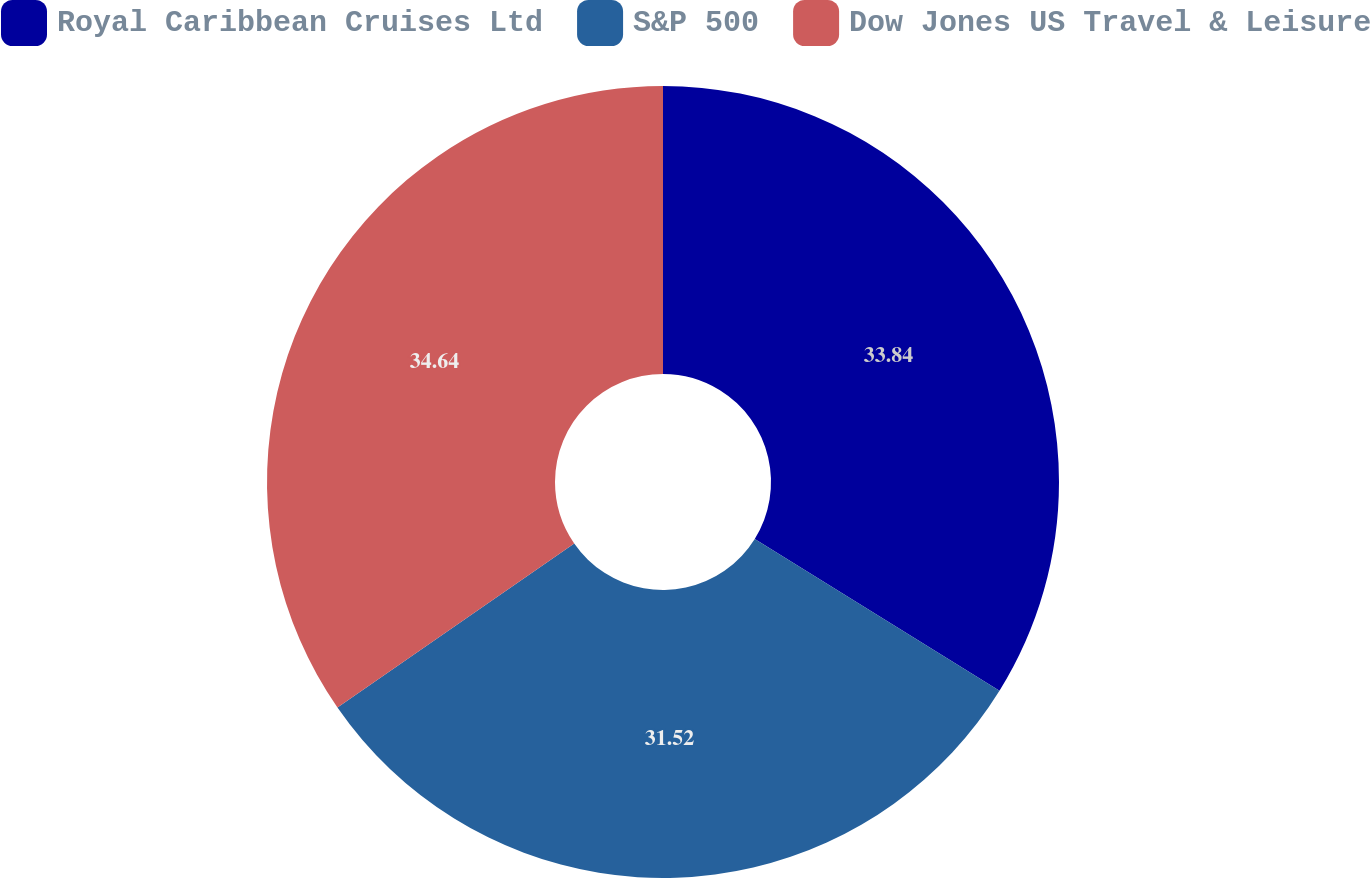<chart> <loc_0><loc_0><loc_500><loc_500><pie_chart><fcel>Royal Caribbean Cruises Ltd<fcel>S&P 500<fcel>Dow Jones US Travel & Leisure<nl><fcel>33.84%<fcel>31.52%<fcel>34.64%<nl></chart> 